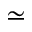Convert formula to latex. <formula><loc_0><loc_0><loc_500><loc_500>\simeq</formula> 